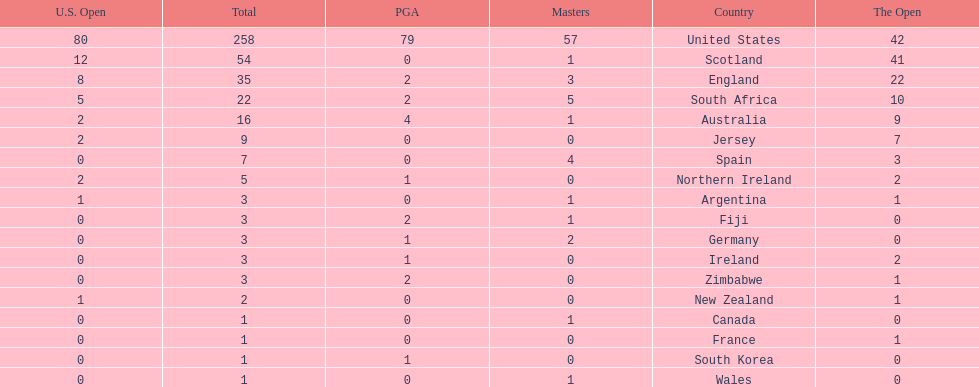Which african country has the least champion golfers according to this table? Zimbabwe. 